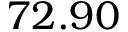Convert formula to latex. <formula><loc_0><loc_0><loc_500><loc_500>7 2 . 9 0</formula> 